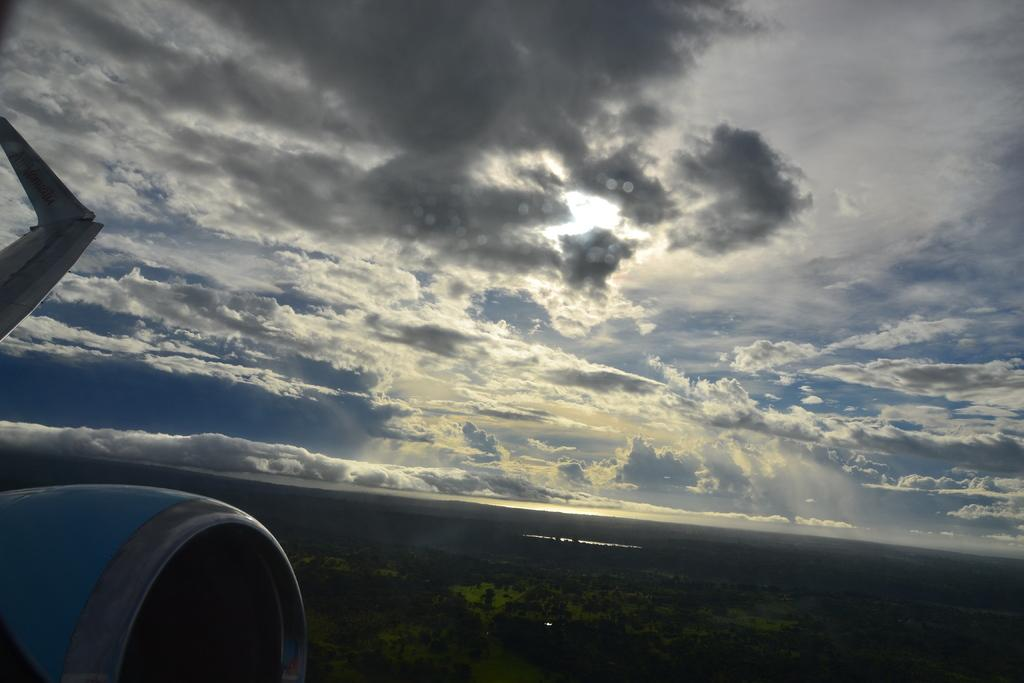What is the perspective of the image? The image is taken from an aeroplane. What can be seen in the sky in the image? There is sky with clouds visible in the image. What type of landscape is visible in the image? There is land with greenery visible in the image. Where is a part of the aeroplane visible in the image? The left bottom of the image contains a part of the aeroplane. What type of fork can be seen in the image? There is no fork present in the image. What kind of wrench is being used to adjust the current in the image? There is no wrench or current present in the image. 